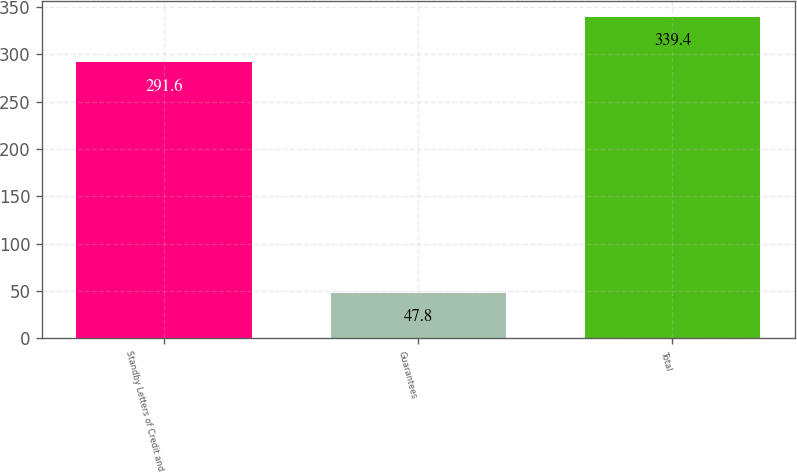Convert chart. <chart><loc_0><loc_0><loc_500><loc_500><bar_chart><fcel>Standby Letters of Credit and<fcel>Guarantees<fcel>Total<nl><fcel>291.6<fcel>47.8<fcel>339.4<nl></chart> 